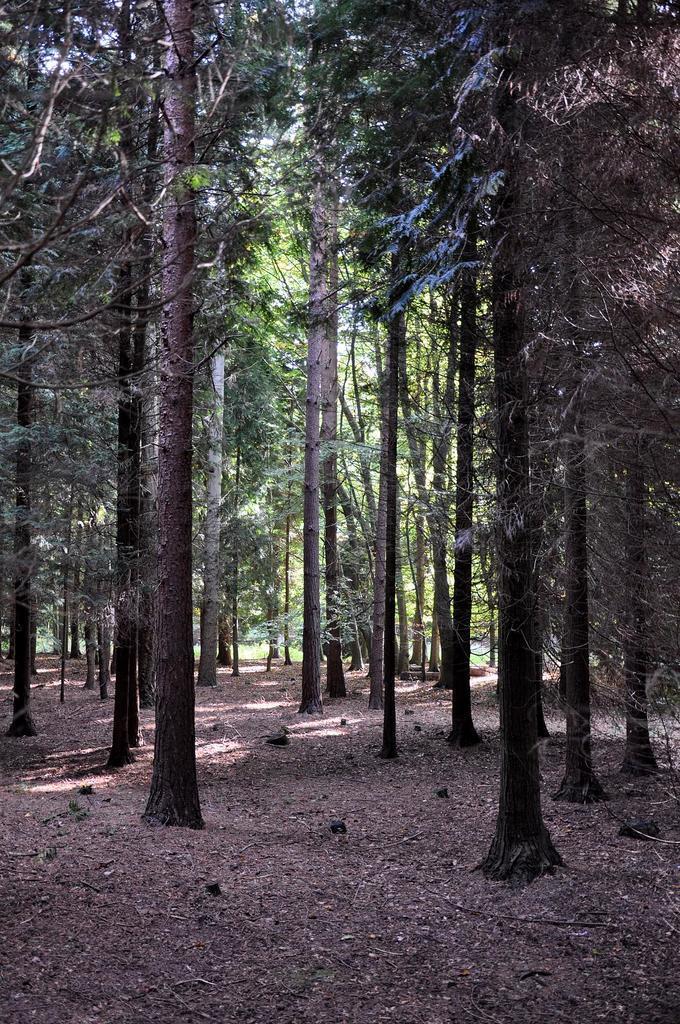In one or two sentences, can you explain what this image depicts? In the picture we can see a surface with a mud on it we can see a number of trees and which is tall. 